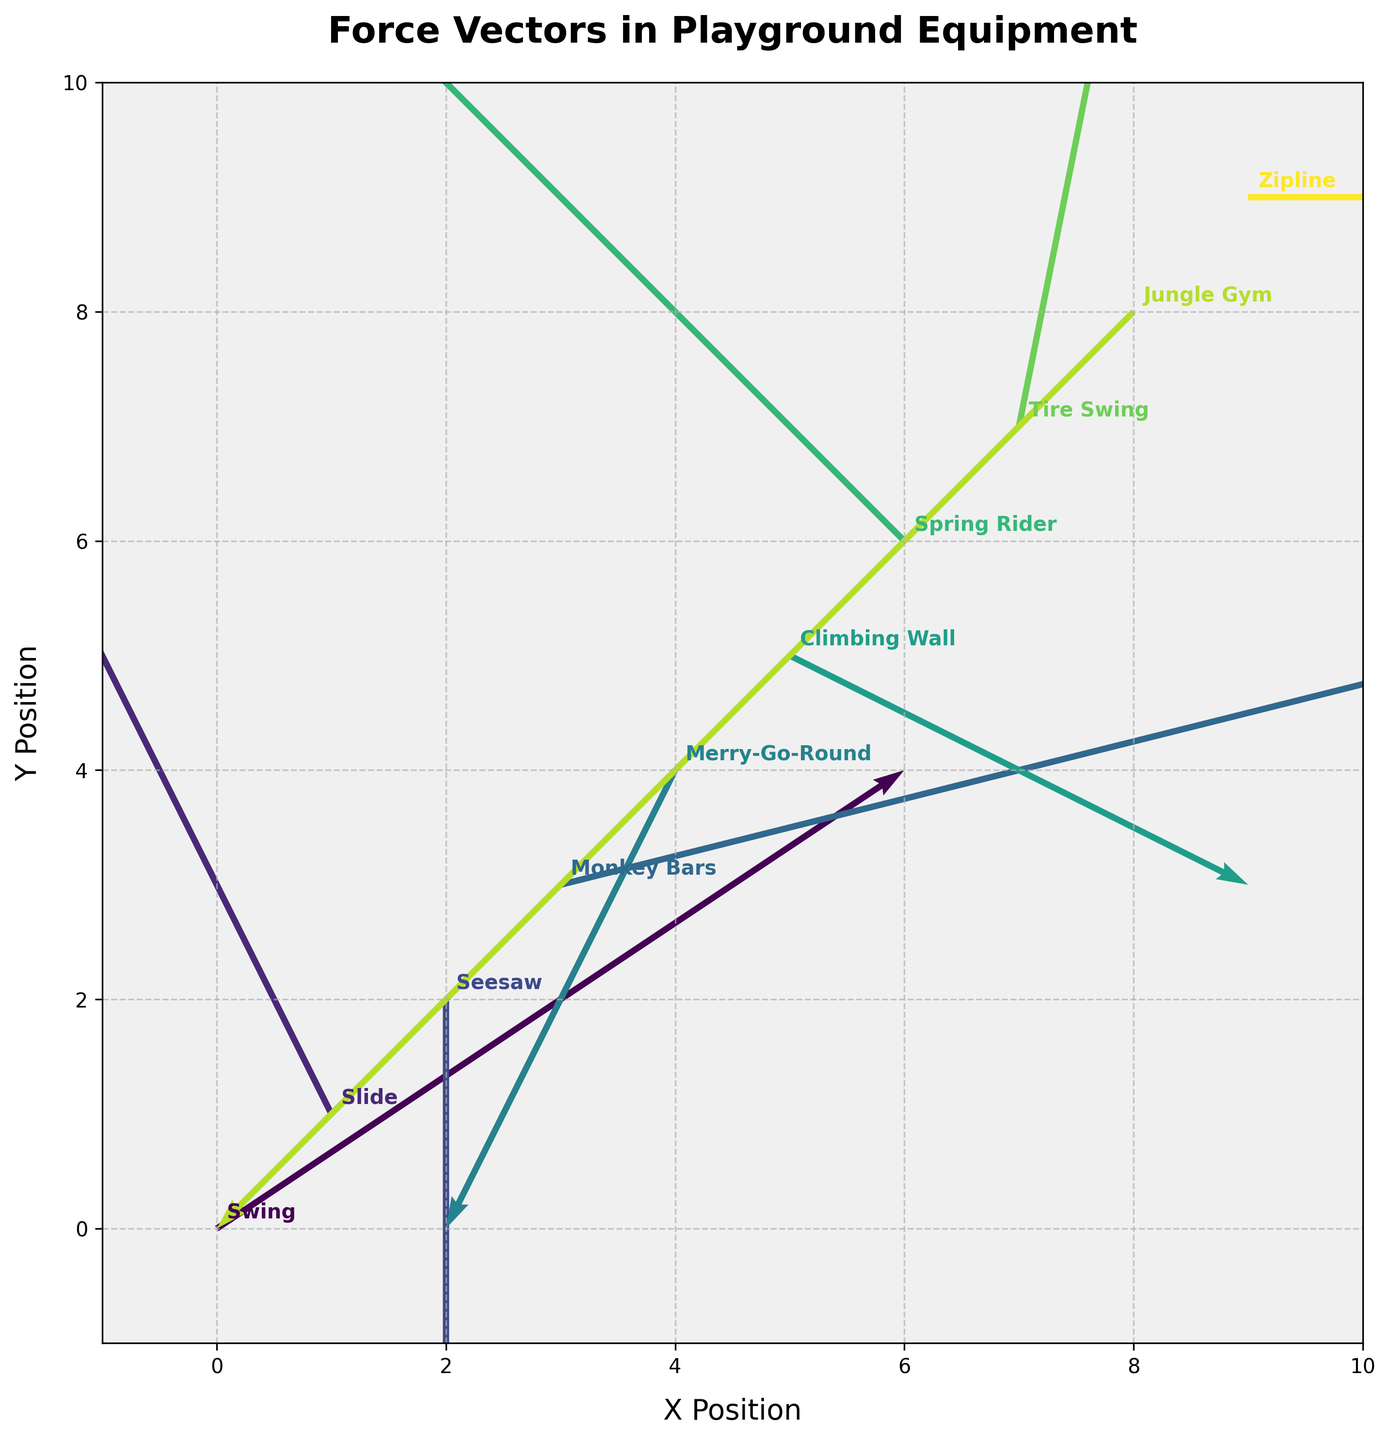what is the title of the figure? The title is typically located at the top of the figure and summarizes the main topic displayed. In this case, the title reads "Force Vectors in Playground Equipment."
Answer: Force Vectors in Playground Equipment How many data points are displayed in the figure? By counting the number of quiver arrows and equipment labels, we see that there are 10 data points in total.
Answer: 10 Which equipment has a force vector with no horizontal component (u=0)? Look for the vector where the horizontal component (u) is 0. The Seesaw at (2, 2) has a force vector with no horizontal component.
Answer: Seesaw What is the vector direction and magnitude for the Tire Swing? The Tire Swing is located at (7, 7) with a vector pointing in the (1, 5) direction. The magnitude of a vector is calculated using the formula √(u^2 + v^2). Here, it's √(1^2 + 5^2) = √26 ≈ 5.10.
Answer: Direction: (1, 5), Magnitude: 5.10 Which equipment has the longest vector, and what is its magnitude? Compare the lengths (magnitudes) of all vectors. The length is calculated as √(u^2 + v^2). The Tire Swing, with u=1 and v=5, has the largest magnitude: √(1^2 + 5^2) = √26 ≈ 5.10.
Answer: Tire Swing, Magnitude: 5.10 Which force vector is pointing directly downwards? Identify the vector with a vertical component (v) negative and a horizontal component (u) of 0. None of the vectors fit this specific criterion.
Answer: None Compare the vectors for the Swing and the Zipline. Which one has a greater magnitude? Calculate √(u^2 + v^2) for both vectors. For Swing, it's √(3^2 + 2^2) = √13 ≈ 3.61. For Zipline, it's √(5^2 + 0^2) = 5. The Zipline has a greater magnitude.
Answer: Zipline What is the average horizontal (u) component of all equipment vectors? Sum the horizontal components (3, -2, 0, 4, -1, 2, -3, 1, -4, 5) and divide by 10. The total is 5, so the average is 5/10 = 0.5.
Answer: 0.5 Which equipment has a vectors pointing in the negative y direction? Identify vectors with a negative vertical component (v). The Seesaw, Merry-Go-Round, Climbing Wall, and Jungle Gym have vectors pointing in the negative y direction.
Answer: Seesaw, Merry-Go-Round, Climbing Wall, Jungle Gym 